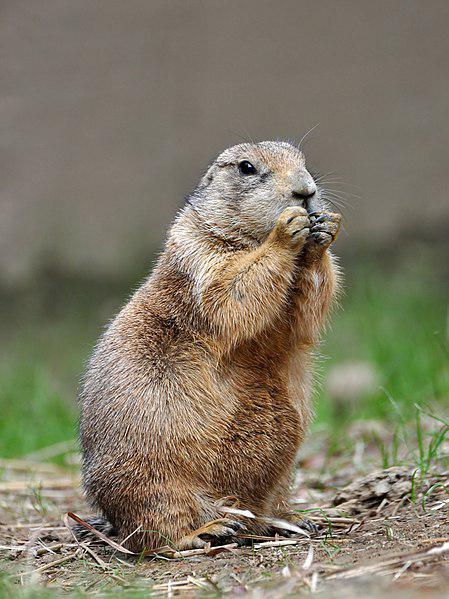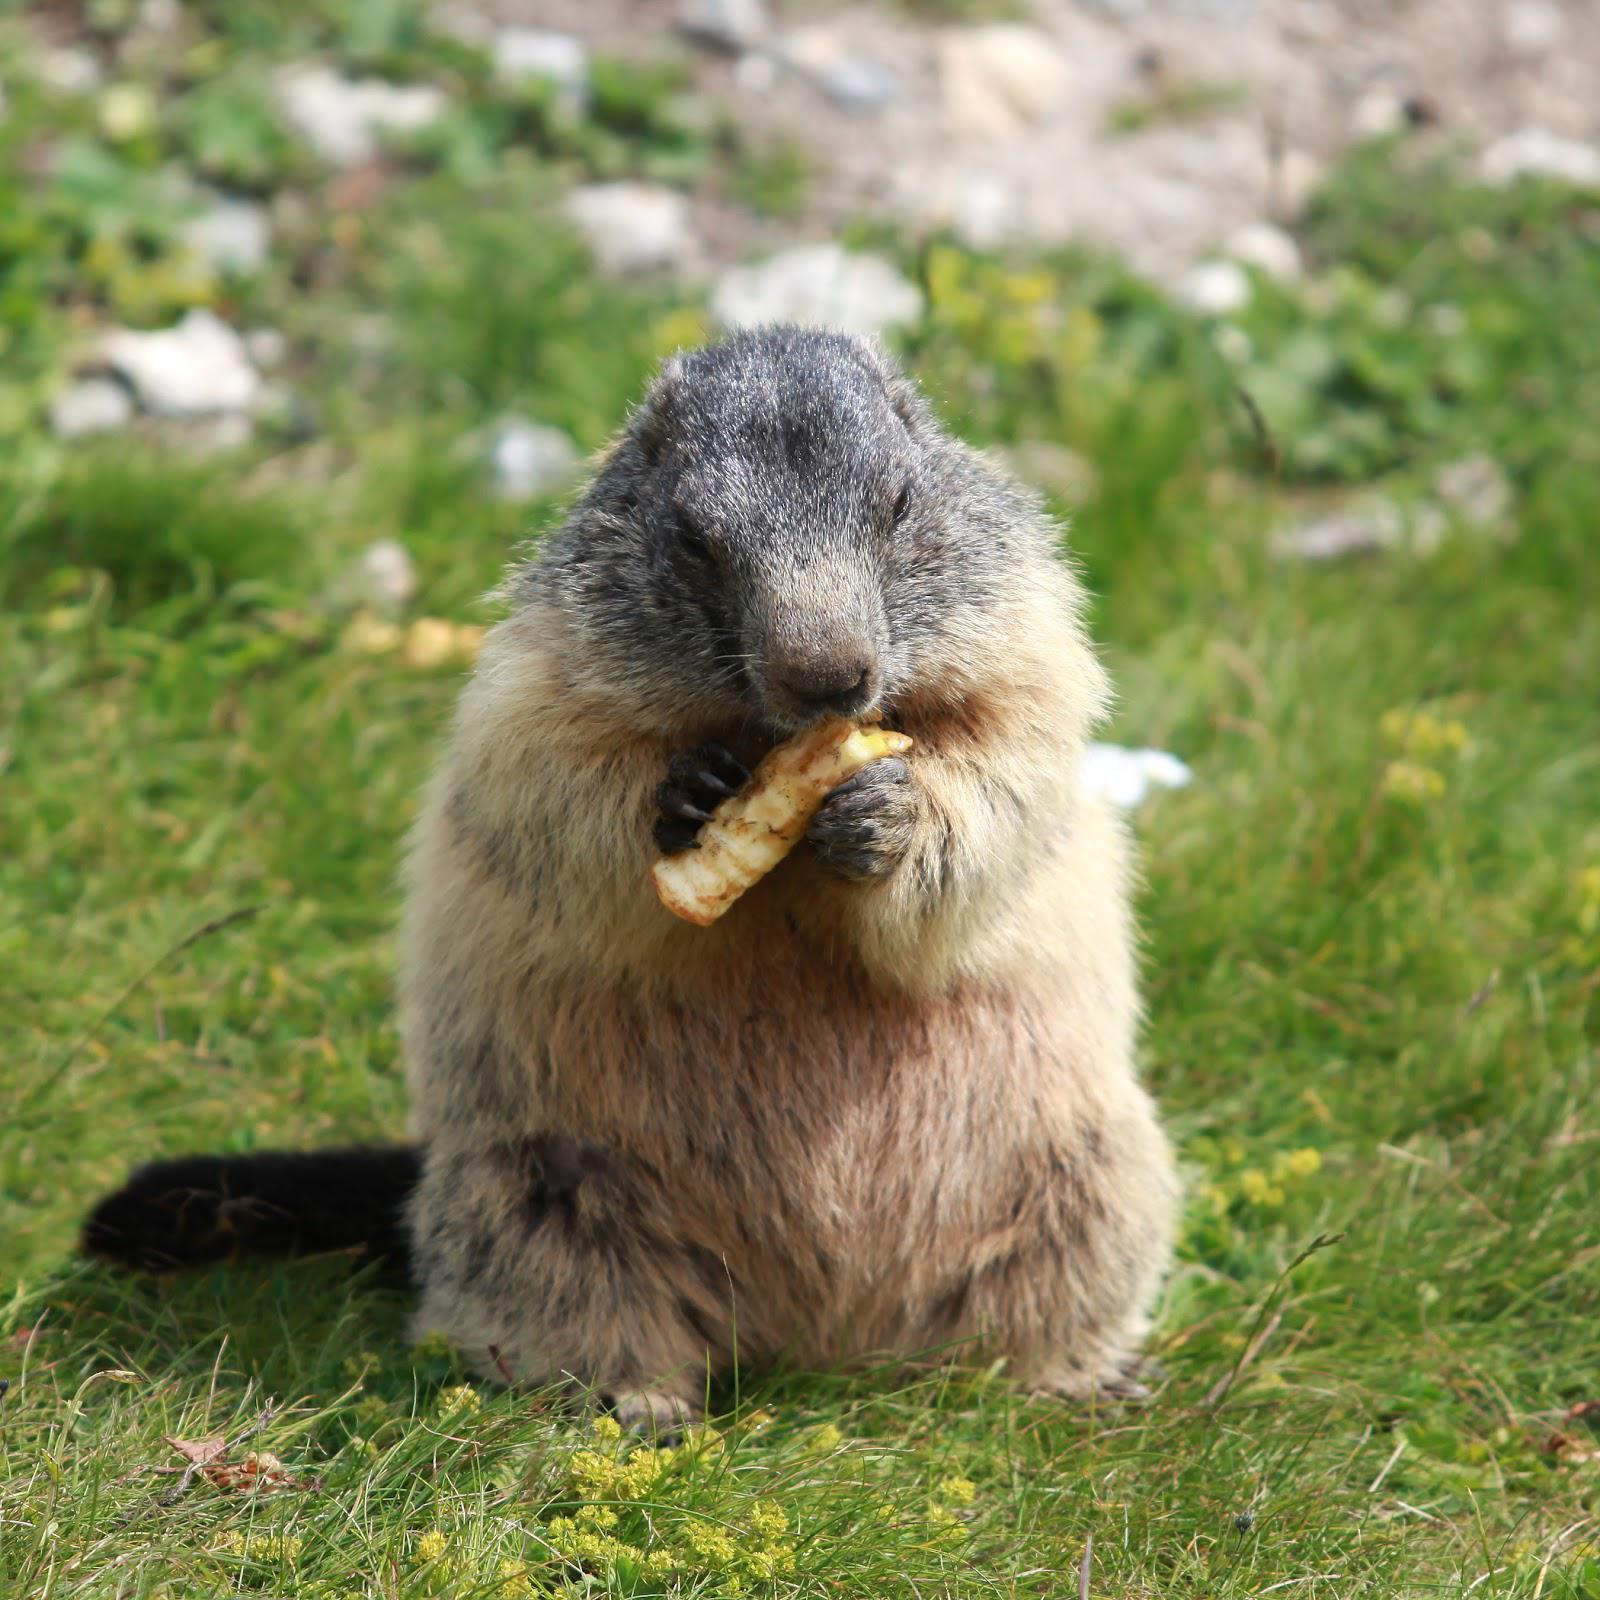The first image is the image on the left, the second image is the image on the right. Considering the images on both sides, is "There is three rodents." valid? Answer yes or no. No. The first image is the image on the left, the second image is the image on the right. Given the left and right images, does the statement "There are three marmots" hold true? Answer yes or no. No. 